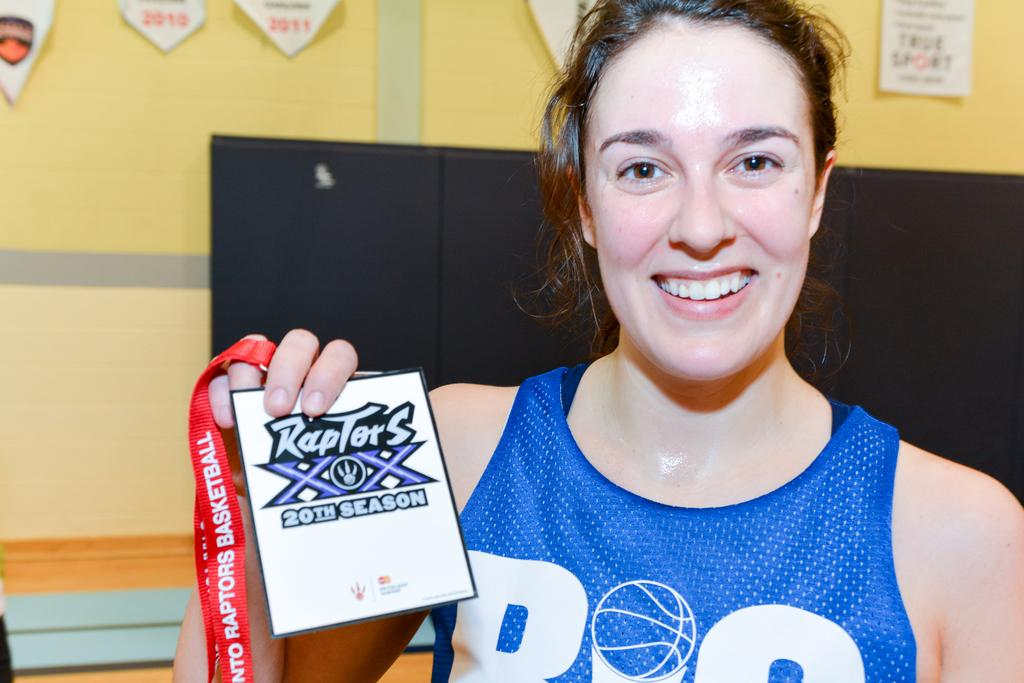Who is in the image? There is a woman in the image. What is the woman doing in the image? The woman is looking at something and smiling. She is also holding cards with tags. What can be seen in the background of the image? There is a black color object, a wall, stickers, and a wooden surface in the background. How much wealth does the doll in the image possess? There is no doll present in the image, so it is not possible to determine the doll's wealth. 